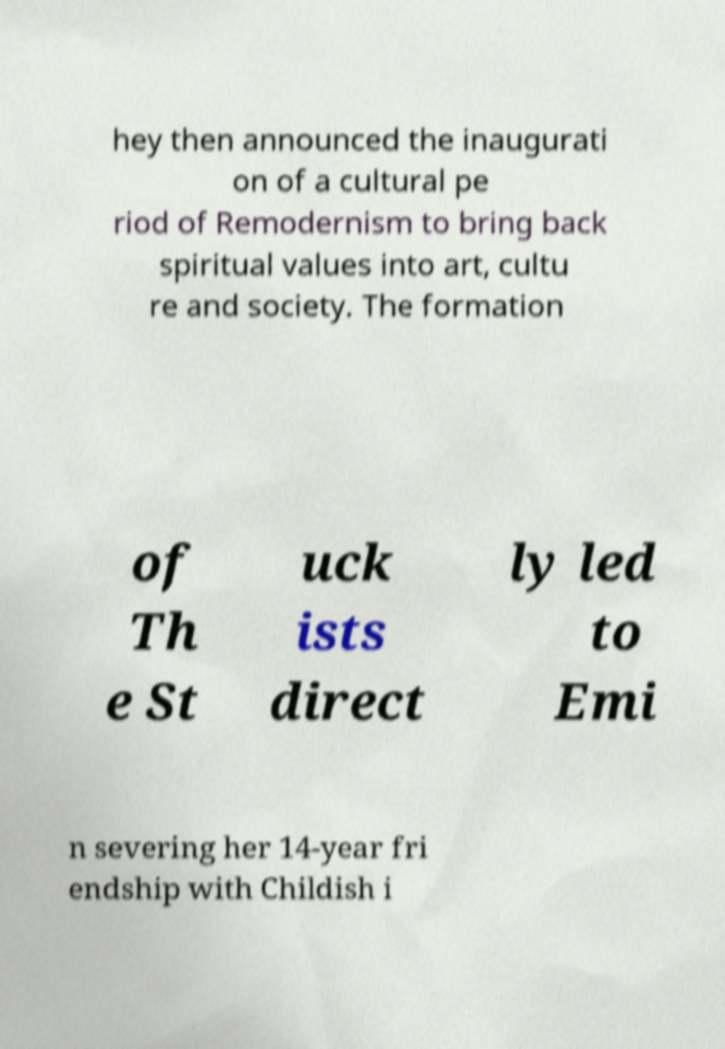Can you accurately transcribe the text from the provided image for me? hey then announced the inaugurati on of a cultural pe riod of Remodernism to bring back spiritual values into art, cultu re and society. The formation of Th e St uck ists direct ly led to Emi n severing her 14-year fri endship with Childish i 